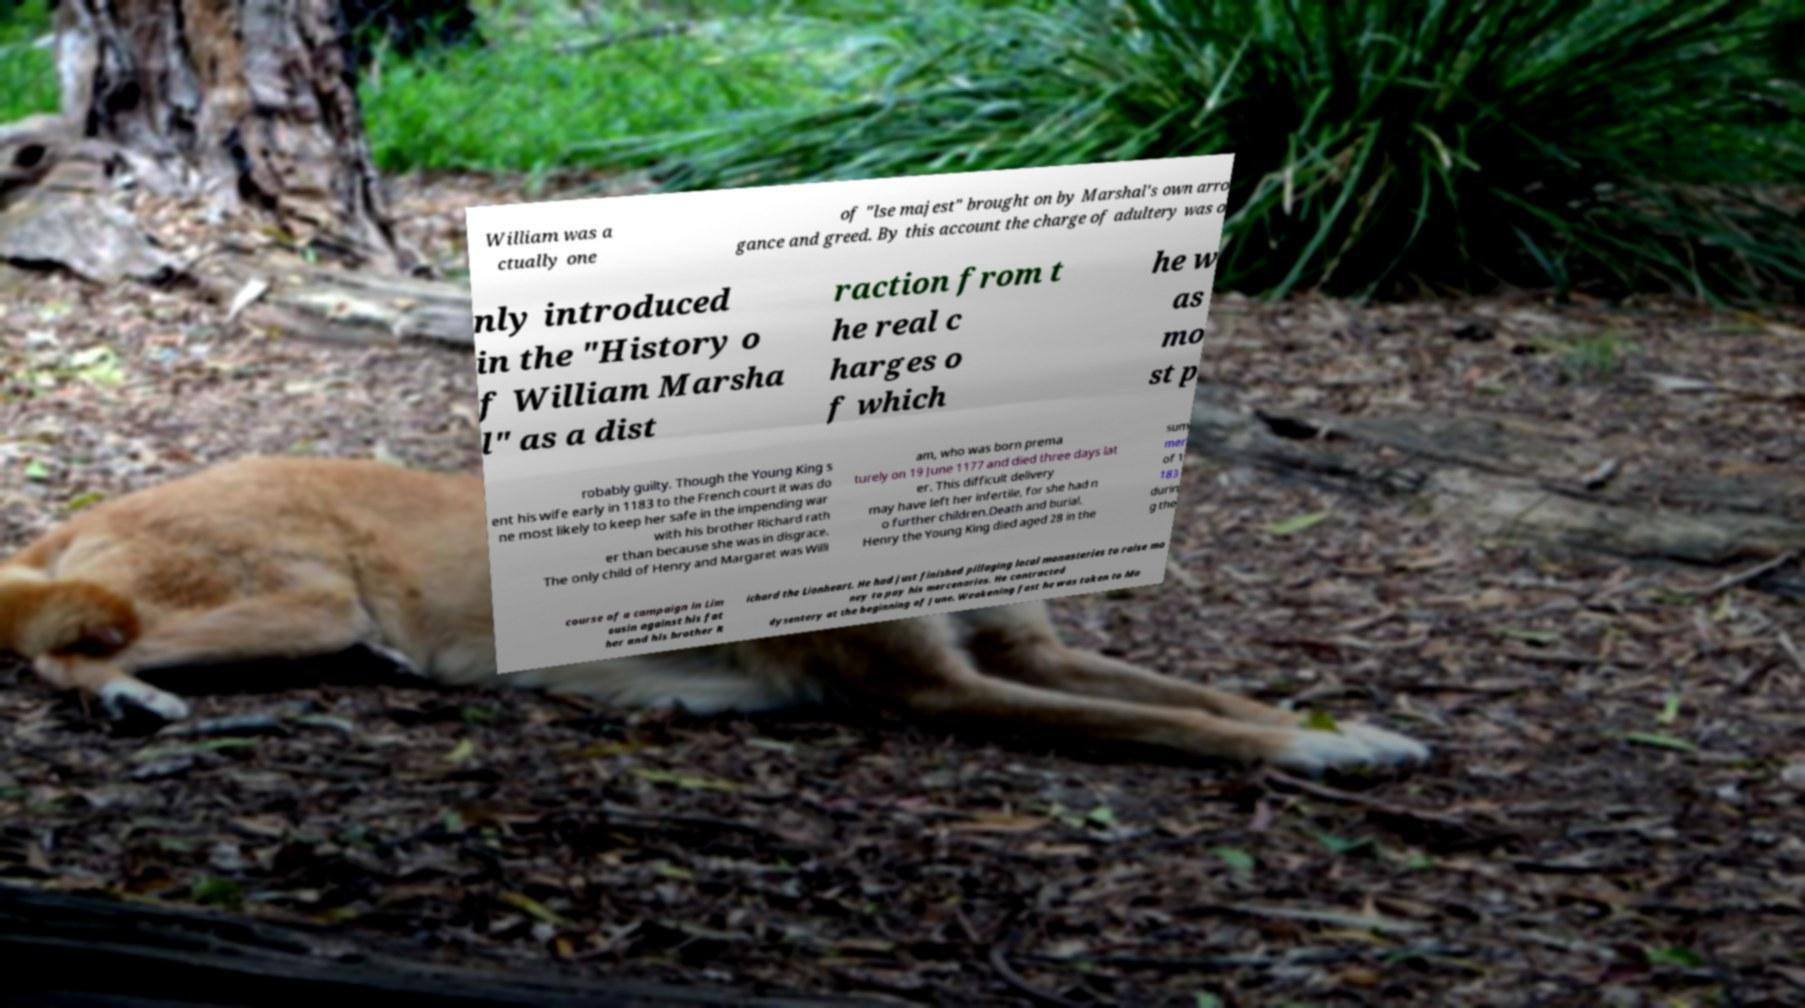What messages or text are displayed in this image? I need them in a readable, typed format. William was a ctually one of "lse majest" brought on by Marshal's own arro gance and greed. By this account the charge of adultery was o nly introduced in the "History o f William Marsha l" as a dist raction from t he real c harges o f which he w as mo st p robably guilty. Though the Young King s ent his wife early in 1183 to the French court it was do ne most likely to keep her safe in the impending war with his brother Richard rath er than because she was in disgrace. The only child of Henry and Margaret was Willi am, who was born prema turely on 19 June 1177 and died three days lat er. This difficult delivery may have left her infertile, for she had n o further children.Death and burial. Henry the Young King died aged 28 in the sum mer of 1 183 durin g the course of a campaign in Lim ousin against his fat her and his brother R ichard the Lionheart. He had just finished pillaging local monasteries to raise mo ney to pay his mercenaries. He contracted dysentery at the beginning of June. Weakening fast he was taken to Ma 